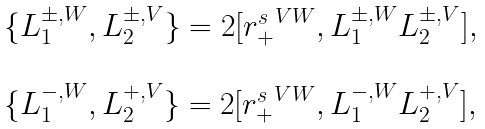Convert formula to latex. <formula><loc_0><loc_0><loc_500><loc_500>\begin{array} { l } \{ L ^ { \pm , W } _ { 1 } , L ^ { \pm , V } _ { 2 } \} = 2 [ { r _ { + } ^ { s } } ^ { V W } , L ^ { \pm , W } _ { 1 } L ^ { \pm , V } _ { 2 } ] , \\ \\ \{ L ^ { - , W } _ { 1 } , L ^ { + , V } _ { 2 } \} = 2 [ { r _ { + } ^ { s } } ^ { V W } , L ^ { - , W } _ { 1 } L ^ { + , V } _ { 2 } ] , \end{array}</formula> 